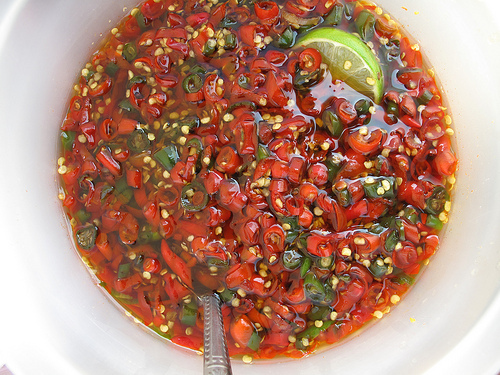<image>
Is the soup above the spoon? No. The soup is not positioned above the spoon. The vertical arrangement shows a different relationship. 